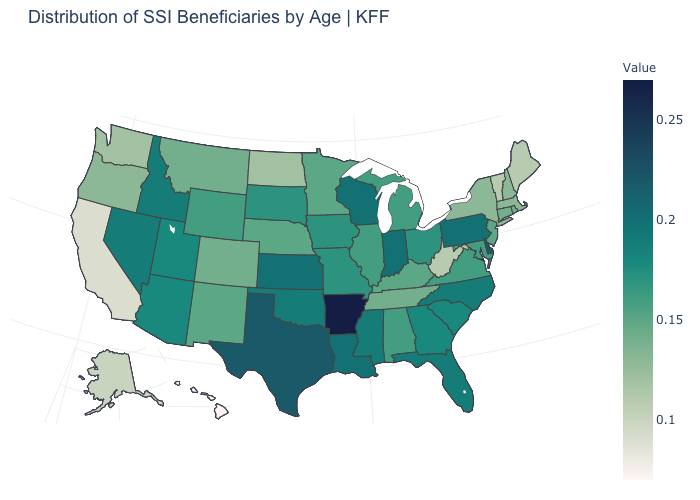Which states have the lowest value in the West?
Concise answer only. Hawaii. Is the legend a continuous bar?
Give a very brief answer. Yes. Which states have the highest value in the USA?
Keep it brief. Arkansas. Which states have the highest value in the USA?
Short answer required. Arkansas. Among the states that border Connecticut , which have the highest value?
Short answer required. Rhode Island. Does Arkansas have the highest value in the USA?
Concise answer only. Yes. 